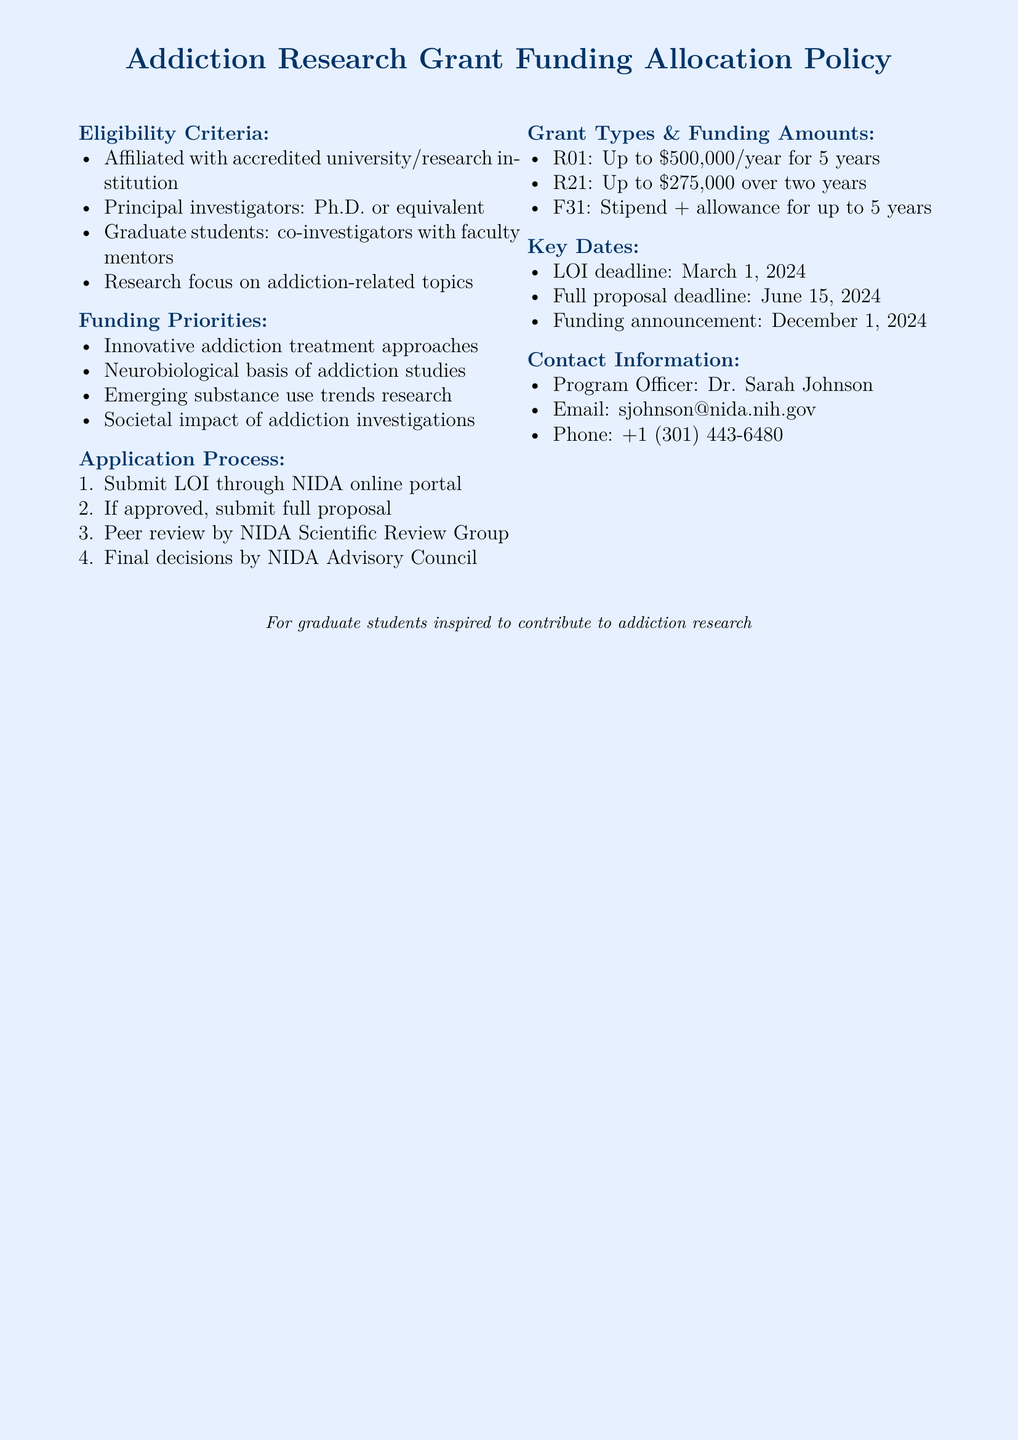What is the maximum funding for an R01 grant? The document states that R01 grants provide funding of up to $500,000 per year.
Answer: Up to $500,000/year Who is the Program Officer? The document lists Dr. Sarah Johnson as the Program Officer for the grants.
Answer: Dr. Sarah Johnson What is the LOI deadline? The document specifies that the Letter of Intent (LOI) deadline is March 1, 2024.
Answer: March 1, 2024 What is required of principal investigators? The eligibility criteria state that principal investigators must have a Ph.D. or equivalent.
Answer: Ph.D. or equivalent What are the funding priorities? The document highlights four funding priorities related to innovative treatment approaches, neurobiological studies, emerging substance use trends, and societal impact research.
Answer: Innovative addiction treatment approaches, neurobiological basis of addiction studies, emerging substance use trends research, societal impact of addiction investigations If a graduate student wants to apply, what must they have? The eligibility criteria indicate that graduate students must have faculty mentors as co-investigators.
Answer: Faculty mentors What is the funding amount for an F31 grant? According to the document, the F31 grant includes a stipend and allowance for up to 5 years.
Answer: Stipend + allowance for up to 5 years How many years can R21 funding be received for? The document specifies that R21 funding can be received for a duration of two years.
Answer: Two years 